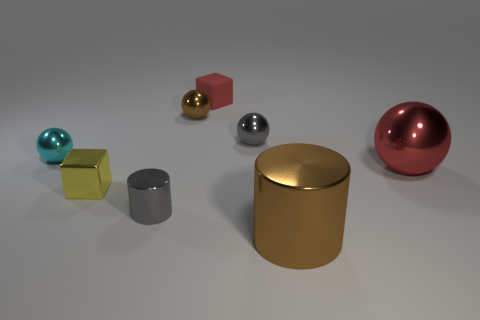What is the material of the cylinder left of the big shiny cylinder?
Your response must be concise. Metal. Are there an equal number of brown cylinders to the left of the tiny red thing and large red shiny things?
Your answer should be compact. No. Are there any other things that are the same size as the red matte object?
Provide a succinct answer. Yes. What material is the red thing that is in front of the metal ball left of the small brown metal thing?
Provide a short and direct response. Metal. The object that is both in front of the small cyan ball and behind the small yellow thing has what shape?
Make the answer very short. Sphere. What is the size of the gray object that is the same shape as the tiny brown thing?
Provide a succinct answer. Small. Is the number of small yellow blocks to the left of the yellow shiny object less than the number of small brown balls?
Keep it short and to the point. Yes. How big is the cylinder that is right of the red matte block?
Keep it short and to the point. Large. What color is the rubber object that is the same shape as the yellow metallic thing?
Your answer should be very brief. Red. What number of small spheres are the same color as the small rubber object?
Make the answer very short. 0. 